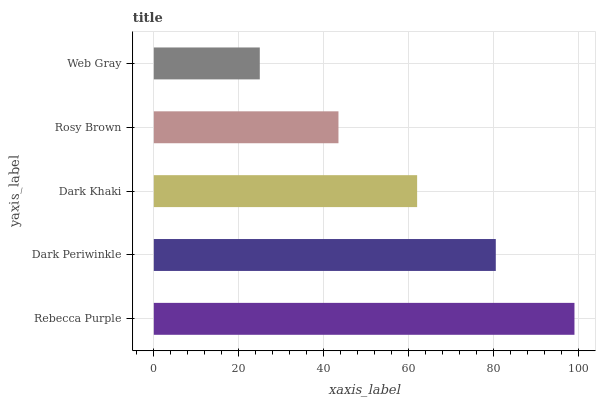Is Web Gray the minimum?
Answer yes or no. Yes. Is Rebecca Purple the maximum?
Answer yes or no. Yes. Is Dark Periwinkle the minimum?
Answer yes or no. No. Is Dark Periwinkle the maximum?
Answer yes or no. No. Is Rebecca Purple greater than Dark Periwinkle?
Answer yes or no. Yes. Is Dark Periwinkle less than Rebecca Purple?
Answer yes or no. Yes. Is Dark Periwinkle greater than Rebecca Purple?
Answer yes or no. No. Is Rebecca Purple less than Dark Periwinkle?
Answer yes or no. No. Is Dark Khaki the high median?
Answer yes or no. Yes. Is Dark Khaki the low median?
Answer yes or no. Yes. Is Rosy Brown the high median?
Answer yes or no. No. Is Rebecca Purple the low median?
Answer yes or no. No. 